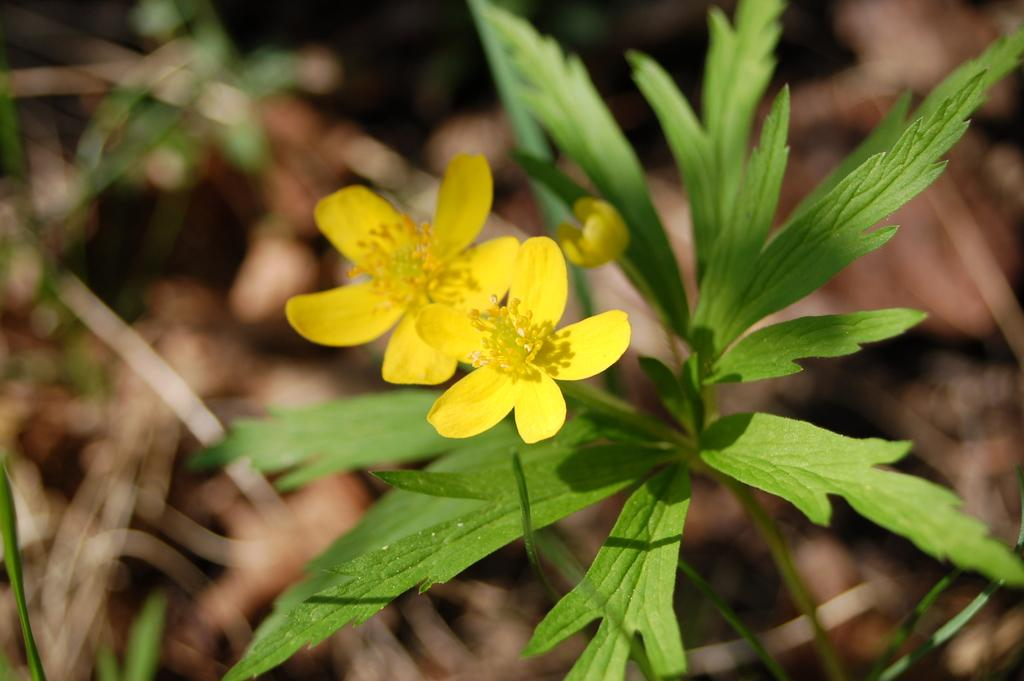What is present in the image? There is a plant in the image. What specific feature of the plant can be observed? The plant has flowers. Can you describe the background of the image? The background of the image is blurred. What type of shirt is being distributed in the image? There is no shirt or distribution present in the image; it features a plant with flowers and a blurred background. 